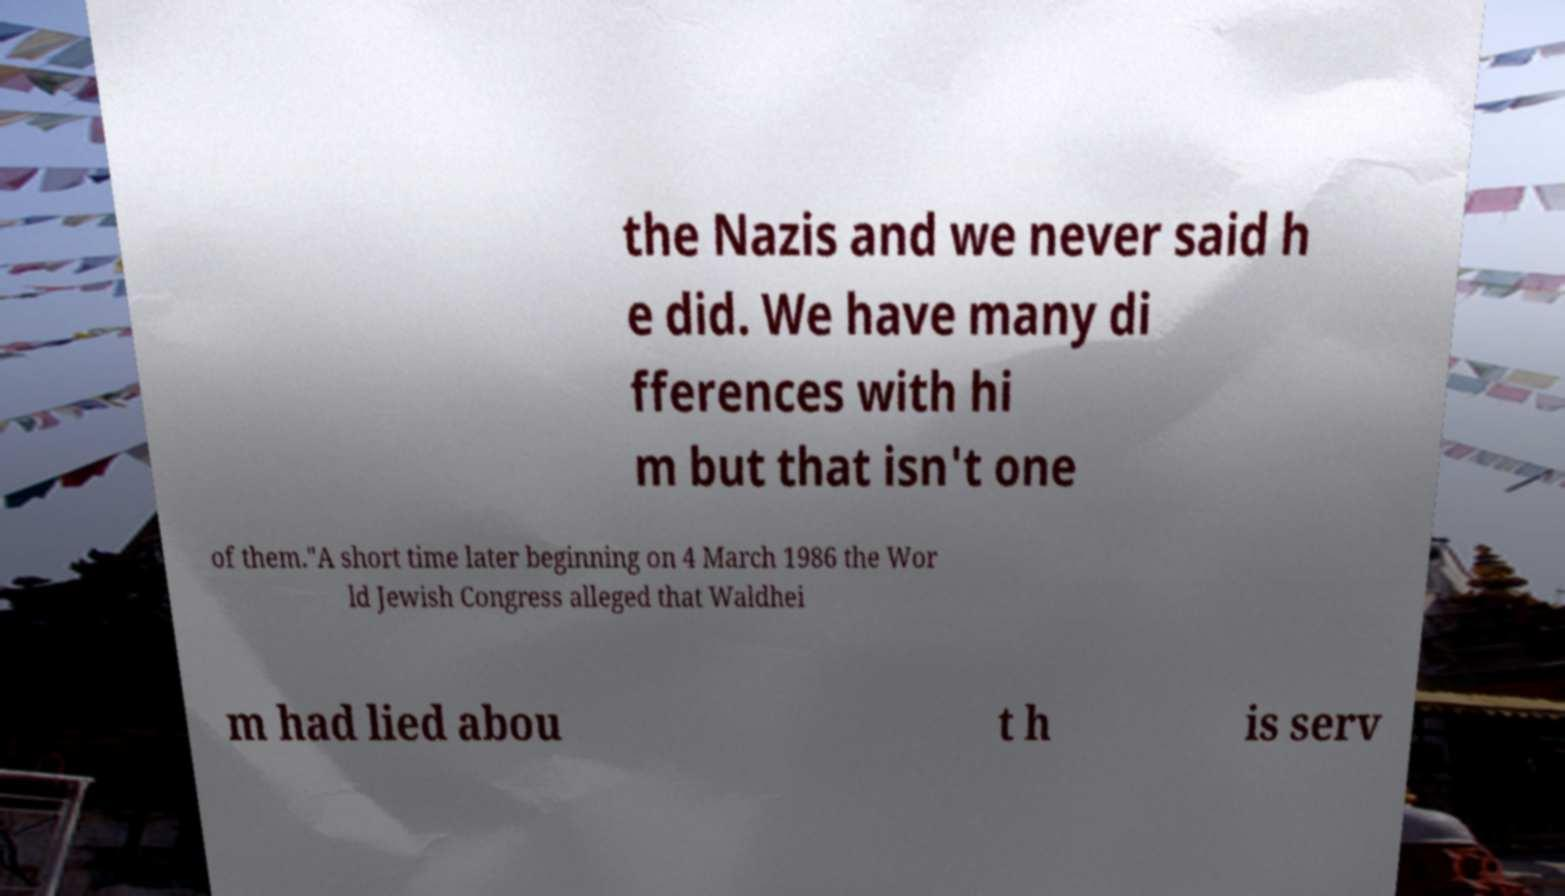Please read and relay the text visible in this image. What does it say? the Nazis and we never said h e did. We have many di fferences with hi m but that isn't one of them."A short time later beginning on 4 March 1986 the Wor ld Jewish Congress alleged that Waldhei m had lied abou t h is serv 